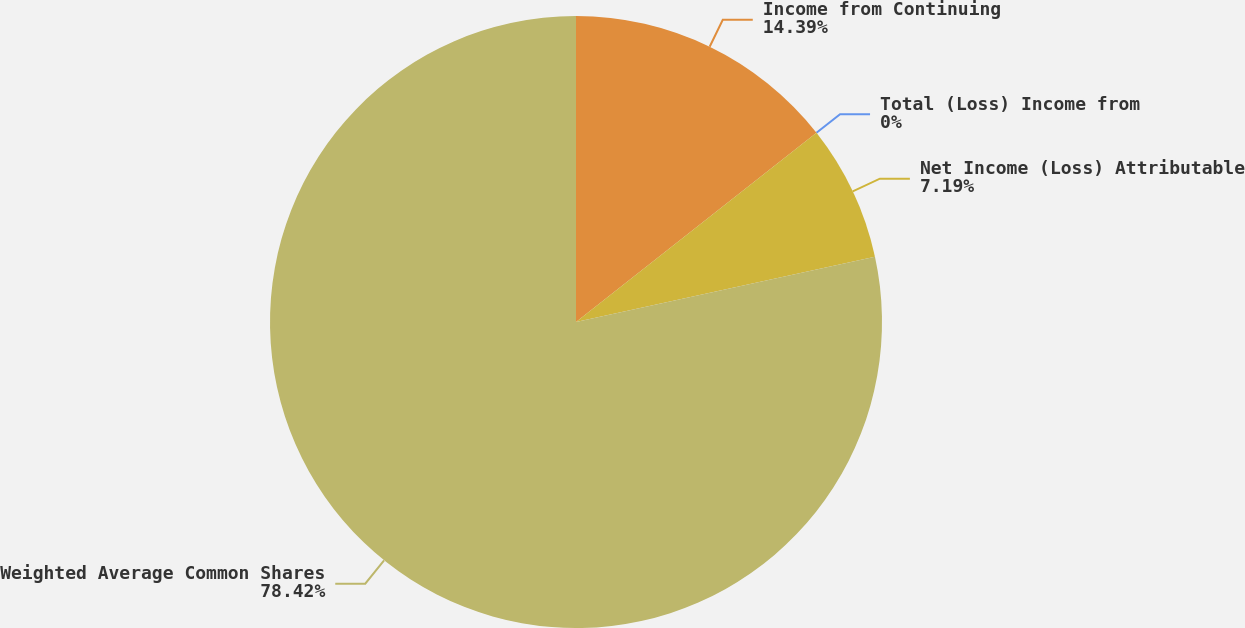<chart> <loc_0><loc_0><loc_500><loc_500><pie_chart><fcel>Income from Continuing<fcel>Total (Loss) Income from<fcel>Net Income (Loss) Attributable<fcel>Weighted Average Common Shares<nl><fcel>14.39%<fcel>0.0%<fcel>7.19%<fcel>78.42%<nl></chart> 